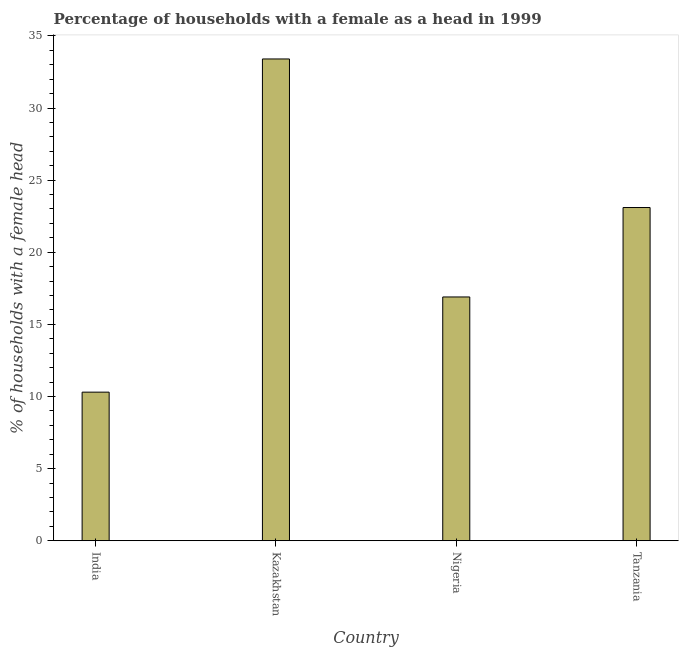Does the graph contain any zero values?
Your answer should be compact. No. What is the title of the graph?
Provide a succinct answer. Percentage of households with a female as a head in 1999. What is the label or title of the Y-axis?
Ensure brevity in your answer.  % of households with a female head. What is the number of female supervised households in Tanzania?
Your answer should be very brief. 23.1. Across all countries, what is the maximum number of female supervised households?
Your answer should be very brief. 33.4. In which country was the number of female supervised households maximum?
Your answer should be very brief. Kazakhstan. In which country was the number of female supervised households minimum?
Give a very brief answer. India. What is the sum of the number of female supervised households?
Offer a terse response. 83.7. What is the difference between the number of female supervised households in India and Tanzania?
Offer a terse response. -12.8. What is the average number of female supervised households per country?
Provide a succinct answer. 20.93. What is the median number of female supervised households?
Provide a short and direct response. 20. What is the ratio of the number of female supervised households in India to that in Tanzania?
Offer a very short reply. 0.45. Is the difference between the number of female supervised households in India and Nigeria greater than the difference between any two countries?
Provide a succinct answer. No. What is the difference between the highest and the second highest number of female supervised households?
Provide a short and direct response. 10.3. Is the sum of the number of female supervised households in Kazakhstan and Nigeria greater than the maximum number of female supervised households across all countries?
Provide a succinct answer. Yes. What is the difference between the highest and the lowest number of female supervised households?
Your response must be concise. 23.1. In how many countries, is the number of female supervised households greater than the average number of female supervised households taken over all countries?
Keep it short and to the point. 2. What is the difference between two consecutive major ticks on the Y-axis?
Your answer should be compact. 5. What is the % of households with a female head of Kazakhstan?
Provide a succinct answer. 33.4. What is the % of households with a female head of Tanzania?
Your answer should be compact. 23.1. What is the difference between the % of households with a female head in India and Kazakhstan?
Provide a succinct answer. -23.1. What is the difference between the % of households with a female head in Kazakhstan and Tanzania?
Your answer should be very brief. 10.3. What is the difference between the % of households with a female head in Nigeria and Tanzania?
Make the answer very short. -6.2. What is the ratio of the % of households with a female head in India to that in Kazakhstan?
Keep it short and to the point. 0.31. What is the ratio of the % of households with a female head in India to that in Nigeria?
Your answer should be compact. 0.61. What is the ratio of the % of households with a female head in India to that in Tanzania?
Ensure brevity in your answer.  0.45. What is the ratio of the % of households with a female head in Kazakhstan to that in Nigeria?
Offer a terse response. 1.98. What is the ratio of the % of households with a female head in Kazakhstan to that in Tanzania?
Your answer should be very brief. 1.45. What is the ratio of the % of households with a female head in Nigeria to that in Tanzania?
Your answer should be very brief. 0.73. 